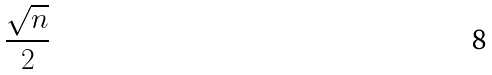<formula> <loc_0><loc_0><loc_500><loc_500>\frac { \sqrt { n } } { 2 }</formula> 